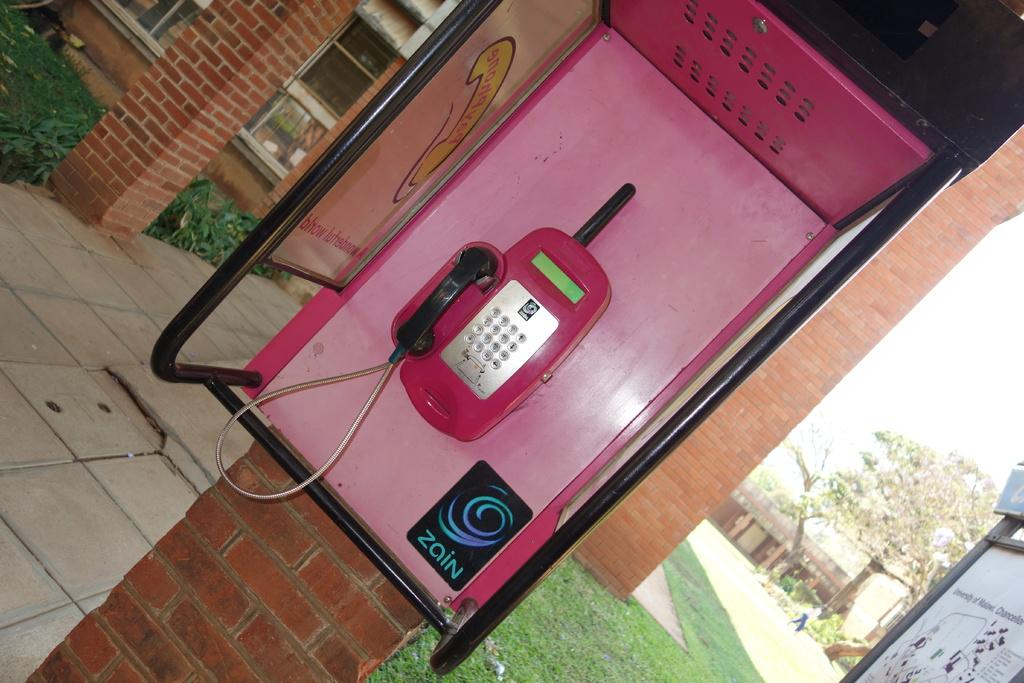<image>
Present a compact description of the photo's key features. A pink phone booth with a sticker that says Zain. 